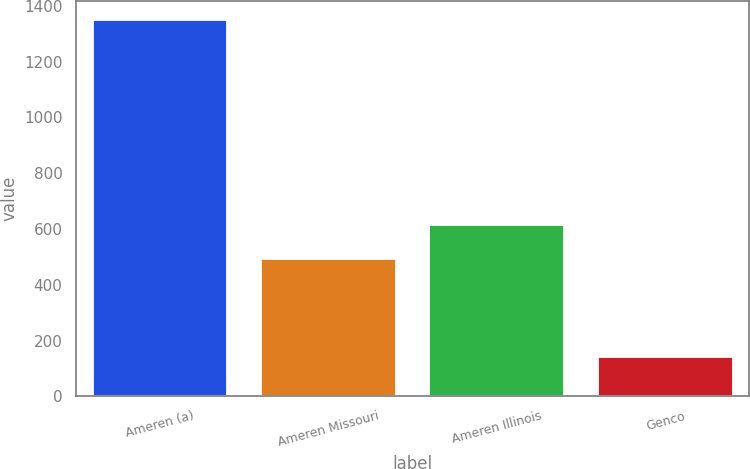Convert chart to OTSL. <chart><loc_0><loc_0><loc_500><loc_500><bar_chart><fcel>Ameren (a)<fcel>Ameren Missouri<fcel>Ameren Illinois<fcel>Genco<nl><fcel>1350<fcel>494<fcel>614.9<fcel>141<nl></chart> 